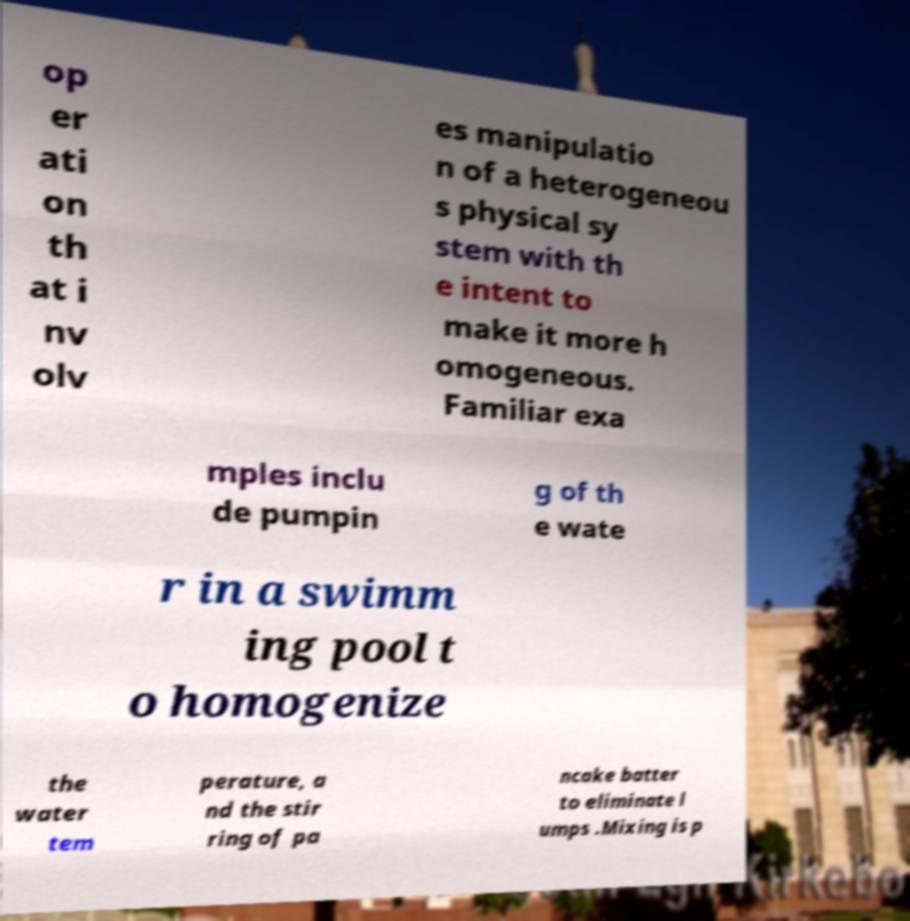I need the written content from this picture converted into text. Can you do that? op er ati on th at i nv olv es manipulatio n of a heterogeneou s physical sy stem with th e intent to make it more h omogeneous. Familiar exa mples inclu de pumpin g of th e wate r in a swimm ing pool t o homogenize the water tem perature, a nd the stir ring of pa ncake batter to eliminate l umps .Mixing is p 